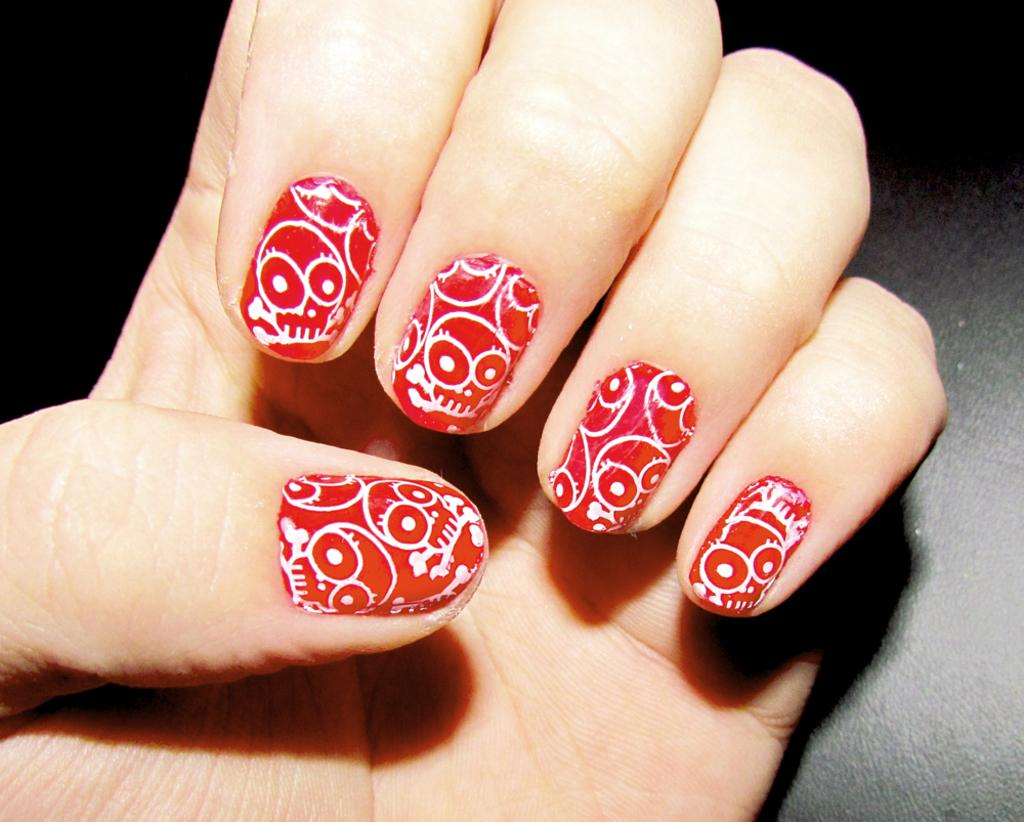What can be seen in the image? There is a hand in the image. What is unique about the hand? The hand has nail art. What type of behavior is the hand exhibiting in the image? The image does not show any specific behavior of the hand, as it is a still image. Is there any powder visible on the hand in the image? There is no mention of powder in the provided facts, so we cannot determine if there is any powder on the hand in the image. 